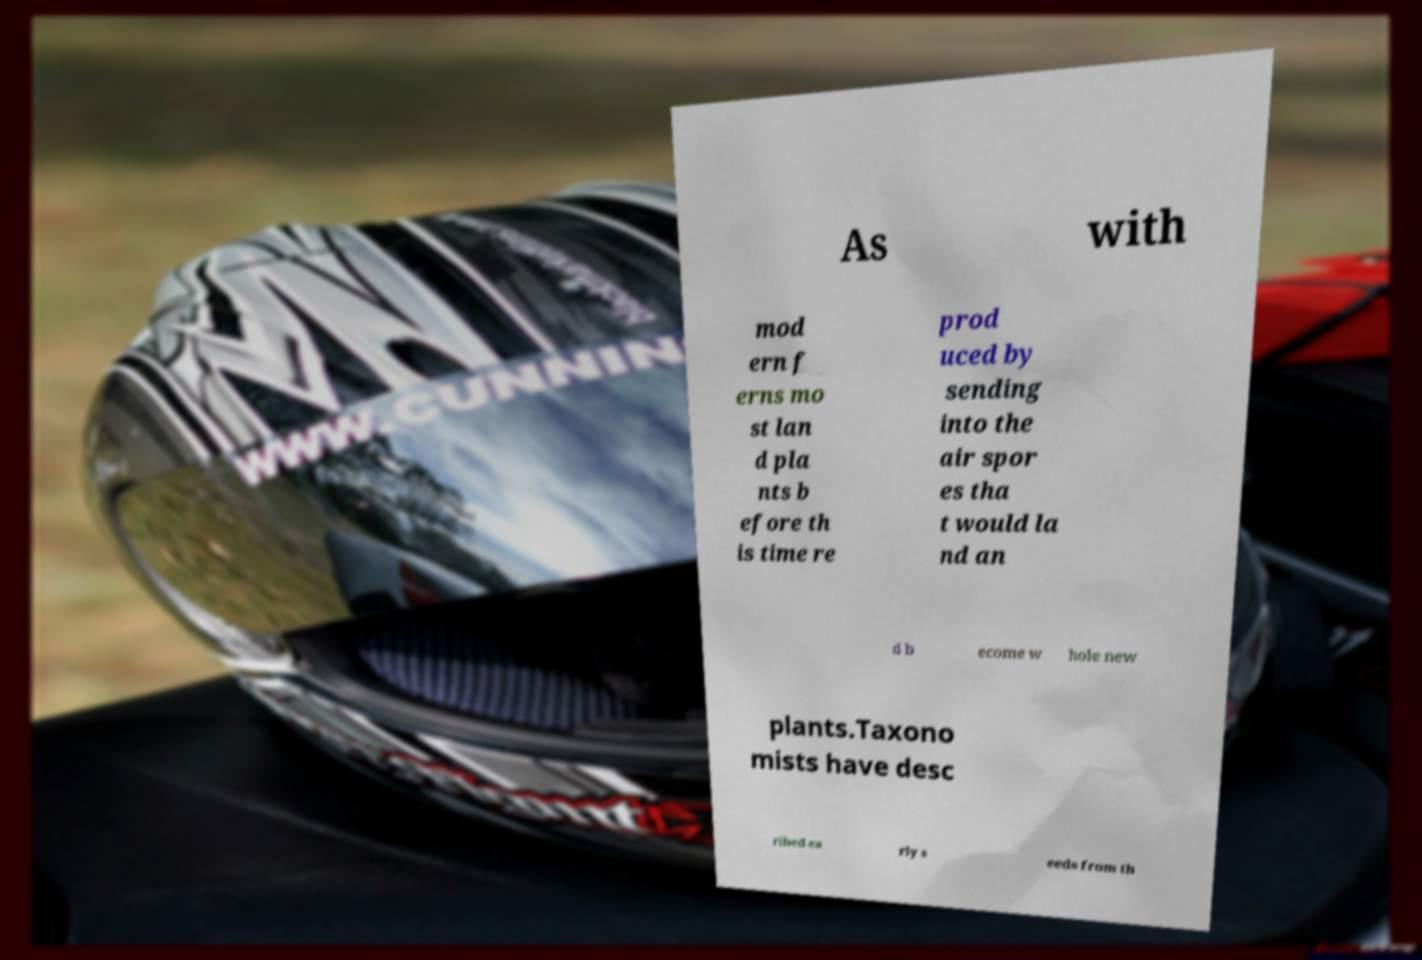There's text embedded in this image that I need extracted. Can you transcribe it verbatim? As with mod ern f erns mo st lan d pla nts b efore th is time re prod uced by sending into the air spor es tha t would la nd an d b ecome w hole new plants.Taxono mists have desc ribed ea rly s eeds from th 